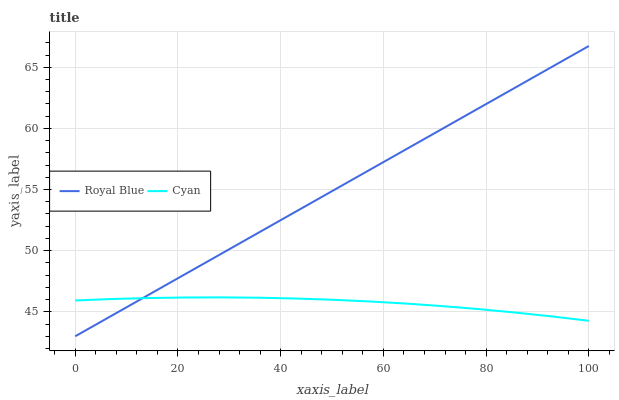Does Cyan have the minimum area under the curve?
Answer yes or no. Yes. Does Royal Blue have the maximum area under the curve?
Answer yes or no. Yes. Does Cyan have the maximum area under the curve?
Answer yes or no. No. Is Royal Blue the smoothest?
Answer yes or no. Yes. Is Cyan the roughest?
Answer yes or no. Yes. Is Cyan the smoothest?
Answer yes or no. No. Does Royal Blue have the lowest value?
Answer yes or no. Yes. Does Cyan have the lowest value?
Answer yes or no. No. Does Royal Blue have the highest value?
Answer yes or no. Yes. Does Cyan have the highest value?
Answer yes or no. No. Does Cyan intersect Royal Blue?
Answer yes or no. Yes. Is Cyan less than Royal Blue?
Answer yes or no. No. Is Cyan greater than Royal Blue?
Answer yes or no. No. 